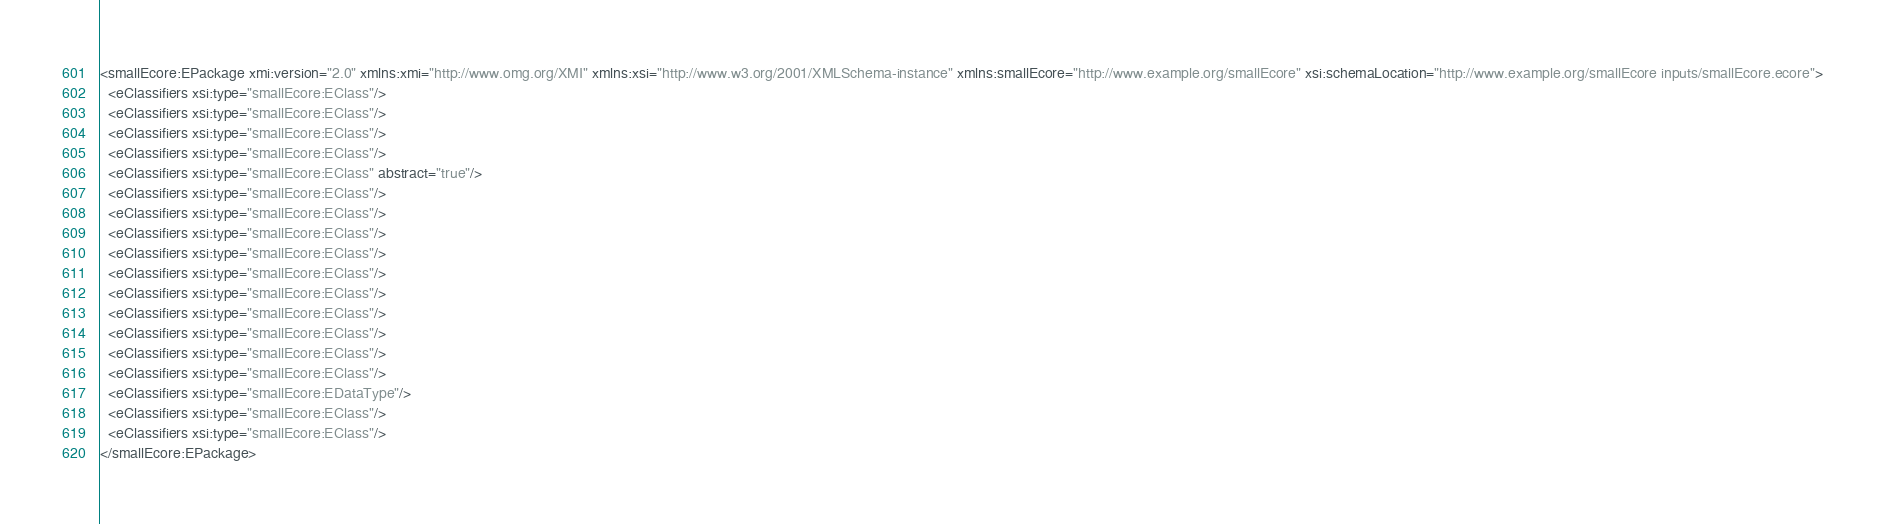Convert code to text. <code><loc_0><loc_0><loc_500><loc_500><_XML_><smallEcore:EPackage xmi:version="2.0" xmlns:xmi="http://www.omg.org/XMI" xmlns:xsi="http://www.w3.org/2001/XMLSchema-instance" xmlns:smallEcore="http://www.example.org/smallEcore" xsi:schemaLocation="http://www.example.org/smallEcore inputs/smallEcore.ecore">
  <eClassifiers xsi:type="smallEcore:EClass"/>
  <eClassifiers xsi:type="smallEcore:EClass"/>
  <eClassifiers xsi:type="smallEcore:EClass"/>
  <eClassifiers xsi:type="smallEcore:EClass"/>
  <eClassifiers xsi:type="smallEcore:EClass" abstract="true"/>
  <eClassifiers xsi:type="smallEcore:EClass"/>
  <eClassifiers xsi:type="smallEcore:EClass"/>
  <eClassifiers xsi:type="smallEcore:EClass"/>
  <eClassifiers xsi:type="smallEcore:EClass"/>
  <eClassifiers xsi:type="smallEcore:EClass"/>
  <eClassifiers xsi:type="smallEcore:EClass"/>
  <eClassifiers xsi:type="smallEcore:EClass"/>
  <eClassifiers xsi:type="smallEcore:EClass"/>
  <eClassifiers xsi:type="smallEcore:EClass"/>
  <eClassifiers xsi:type="smallEcore:EClass"/>
  <eClassifiers xsi:type="smallEcore:EDataType"/>
  <eClassifiers xsi:type="smallEcore:EClass"/>
  <eClassifiers xsi:type="smallEcore:EClass"/>
</smallEcore:EPackage>
</code> 